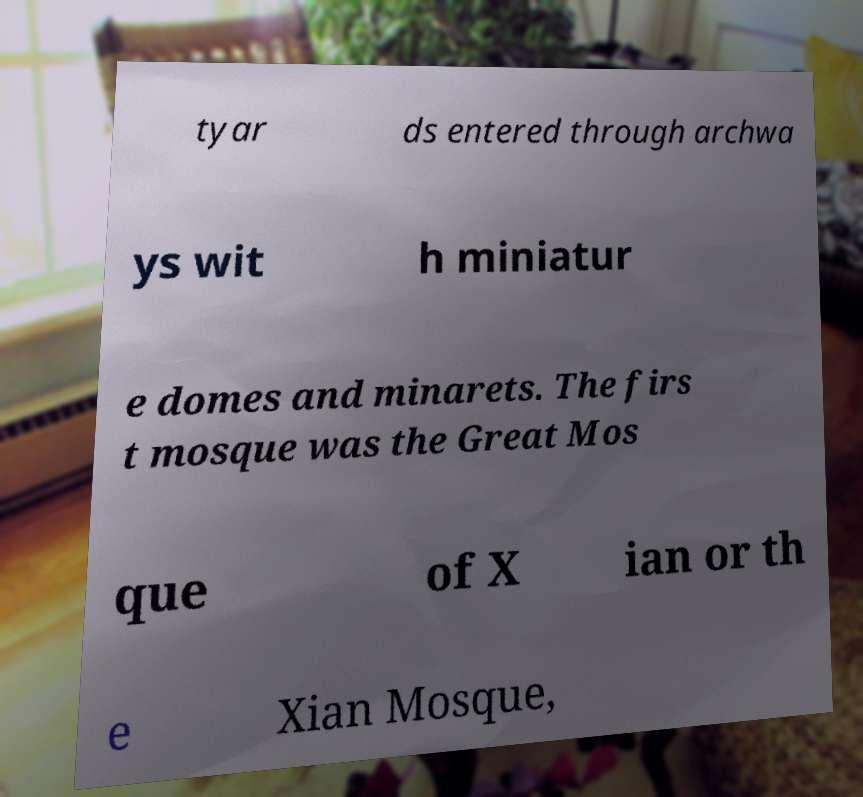What messages or text are displayed in this image? I need them in a readable, typed format. tyar ds entered through archwa ys wit h miniatur e domes and minarets. The firs t mosque was the Great Mos que of X ian or th e Xian Mosque, 